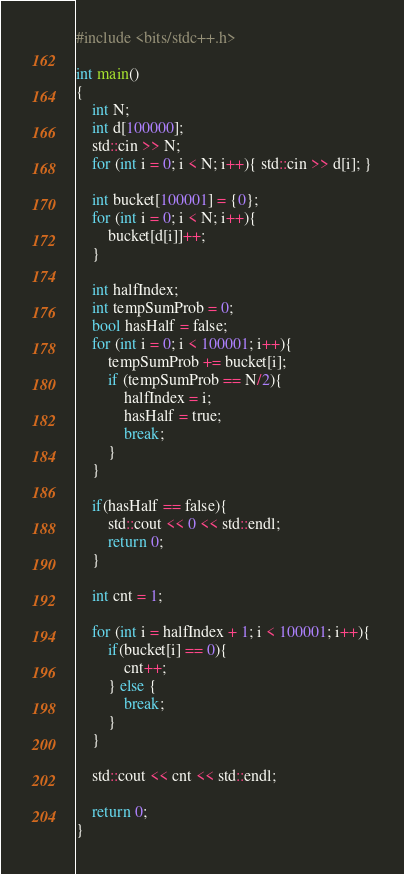Convert code to text. <code><loc_0><loc_0><loc_500><loc_500><_C++_>#include <bits/stdc++.h>

int main()
{
    int N;
    int d[100000];
    std::cin >> N;
    for (int i = 0; i < N; i++){ std::cin >> d[i]; }

    int bucket[100001] = {0};
    for (int i = 0; i < N; i++){
        bucket[d[i]]++;
    }

    int halfIndex;
    int tempSumProb = 0;
    bool hasHalf = false;
    for (int i = 0; i < 100001; i++){
        tempSumProb += bucket[i];
        if (tempSumProb == N/2){
            halfIndex = i;
            hasHalf = true;
            break;
        }
    }

    if(hasHalf == false){ 
        std::cout << 0 << std::endl;
        return 0;
    }

    int cnt = 1;

    for (int i = halfIndex + 1; i < 100001; i++){
        if(bucket[i] == 0){
            cnt++;
        } else {
            break;
        }
    }

    std::cout << cnt << std::endl;

    return 0;
}</code> 